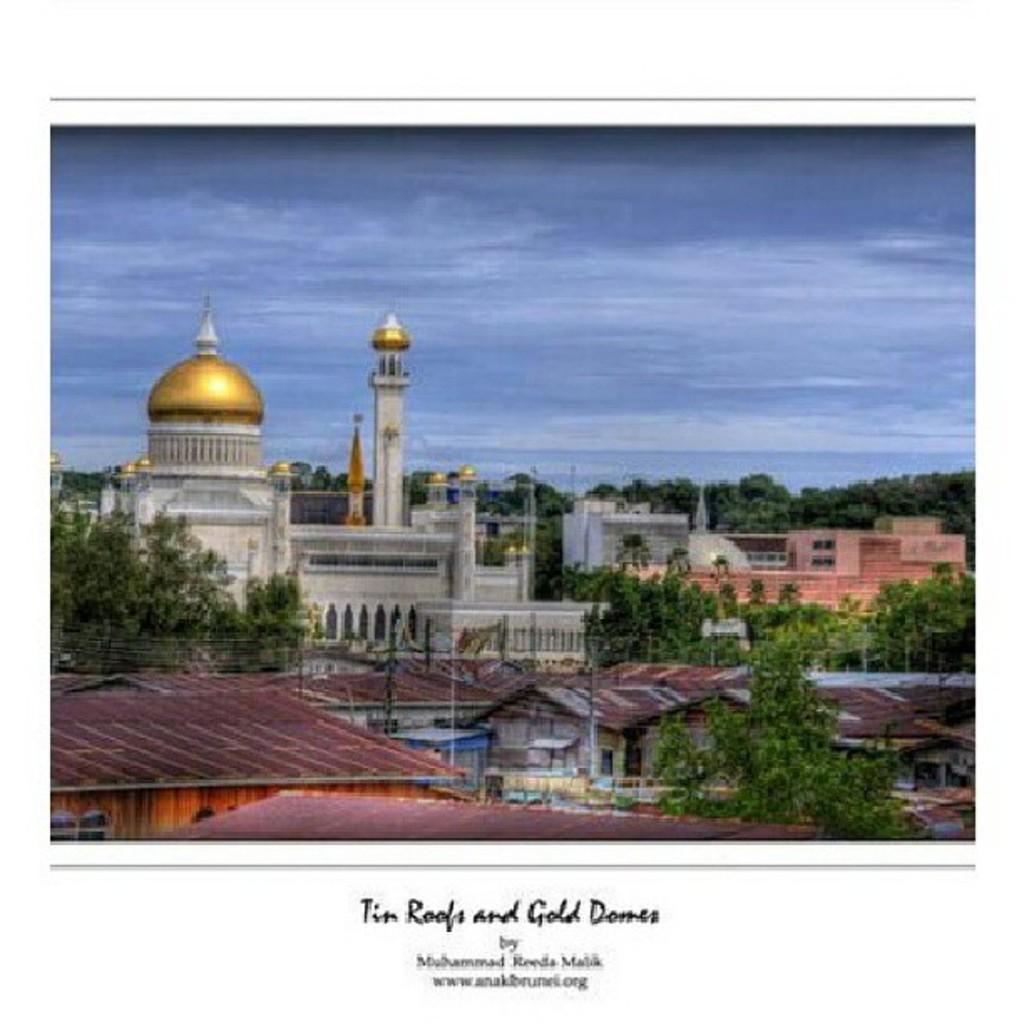What type of structures can be seen in the image? There are houses, buildings, and towers in the image. What other natural elements are present in the image? There are trees in the image. Is there any symbol or emblem visible in the image? Yes, there is a flag in the image. What is visible at the top of the image? The sky is visible at the top of the image. How would you describe the weather in the image? The sky is cloudy in the image. Where are the kittens playing in the image? There are no kittens present in the image. How does the scarecrow contribute to the image? There is no scarecrow present in the image. 